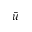<formula> <loc_0><loc_0><loc_500><loc_500>\bar { u }</formula> 